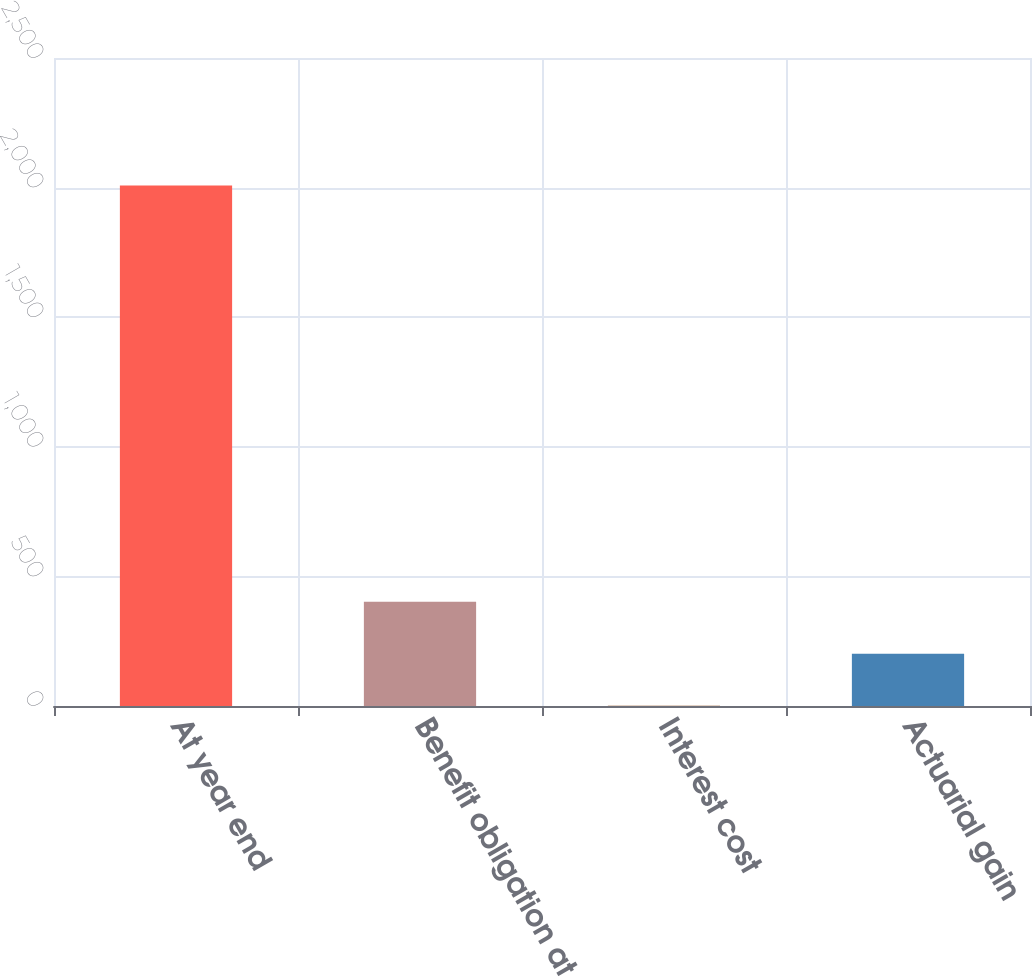<chart> <loc_0><loc_0><loc_500><loc_500><bar_chart><fcel>At year end<fcel>Benefit obligation at<fcel>Interest cost<fcel>Actuarial gain<nl><fcel>2008<fcel>402.4<fcel>1<fcel>201.7<nl></chart> 